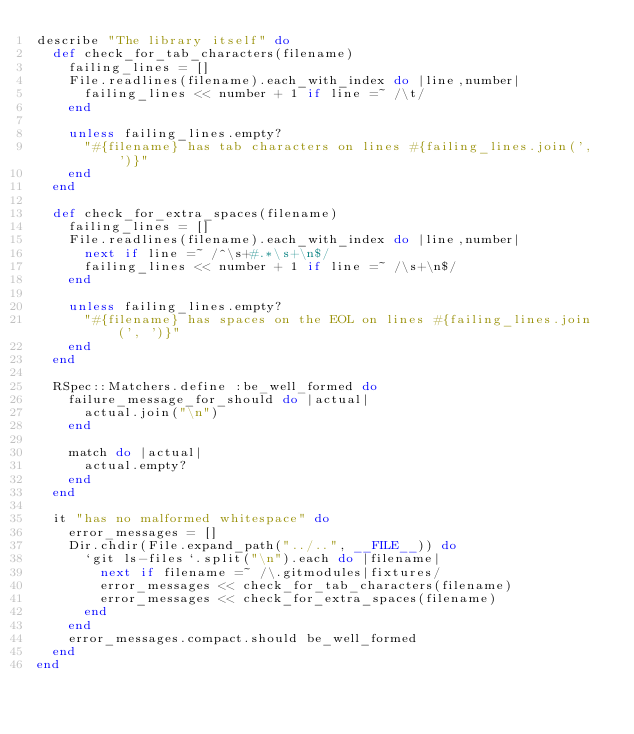Convert code to text. <code><loc_0><loc_0><loc_500><loc_500><_Ruby_>describe "The library itself" do
  def check_for_tab_characters(filename)
    failing_lines = []
    File.readlines(filename).each_with_index do |line,number|
      failing_lines << number + 1 if line =~ /\t/
    end

    unless failing_lines.empty?
      "#{filename} has tab characters on lines #{failing_lines.join(', ')}"
    end
  end

  def check_for_extra_spaces(filename)
    failing_lines = []
    File.readlines(filename).each_with_index do |line,number|
      next if line =~ /^\s+#.*\s+\n$/
      failing_lines << number + 1 if line =~ /\s+\n$/
    end

    unless failing_lines.empty?
      "#{filename} has spaces on the EOL on lines #{failing_lines.join(', ')}"
    end
  end

  RSpec::Matchers.define :be_well_formed do
    failure_message_for_should do |actual|
      actual.join("\n")
    end

    match do |actual|
      actual.empty?
    end
  end

  it "has no malformed whitespace" do
    error_messages = []
    Dir.chdir(File.expand_path("../..", __FILE__)) do
      `git ls-files`.split("\n").each do |filename|
        next if filename =~ /\.gitmodules|fixtures/
        error_messages << check_for_tab_characters(filename)
        error_messages << check_for_extra_spaces(filename)
      end
    end
    error_messages.compact.should be_well_formed
  end
end
</code> 